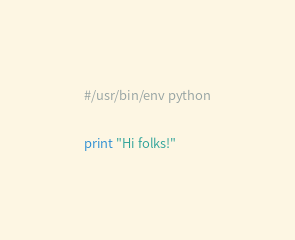<code> <loc_0><loc_0><loc_500><loc_500><_Python_>#/usr/bin/env python

print "Hi folks!"
</code> 